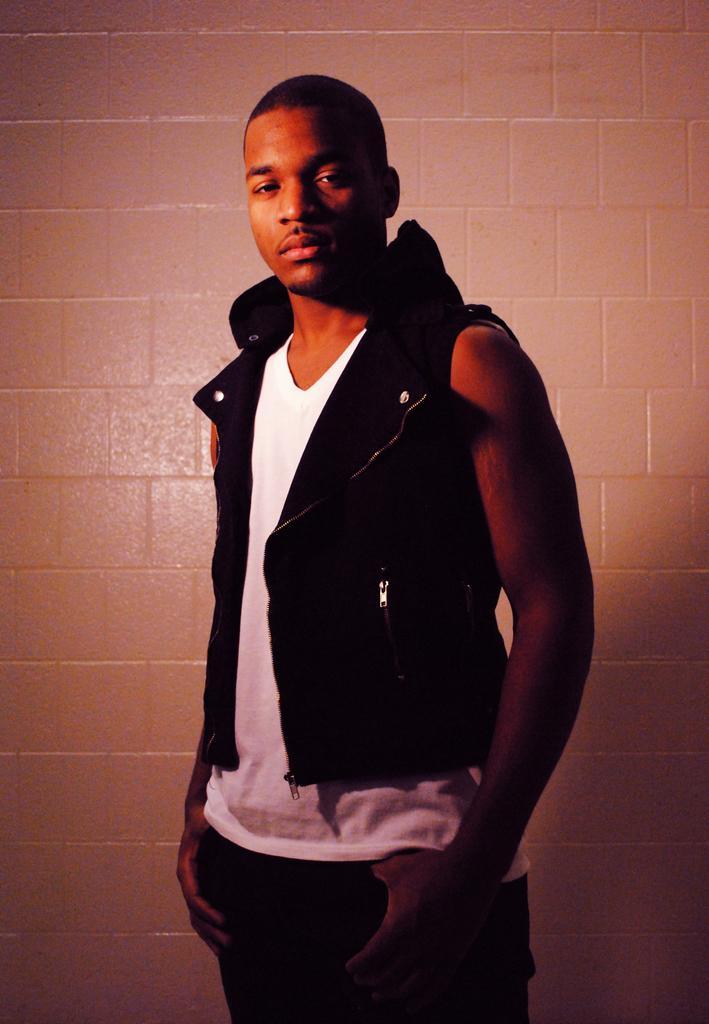Can you describe this image briefly? In the image there is a man standing in front of a wall and posing for the photo, he is wearing a black jacket. 